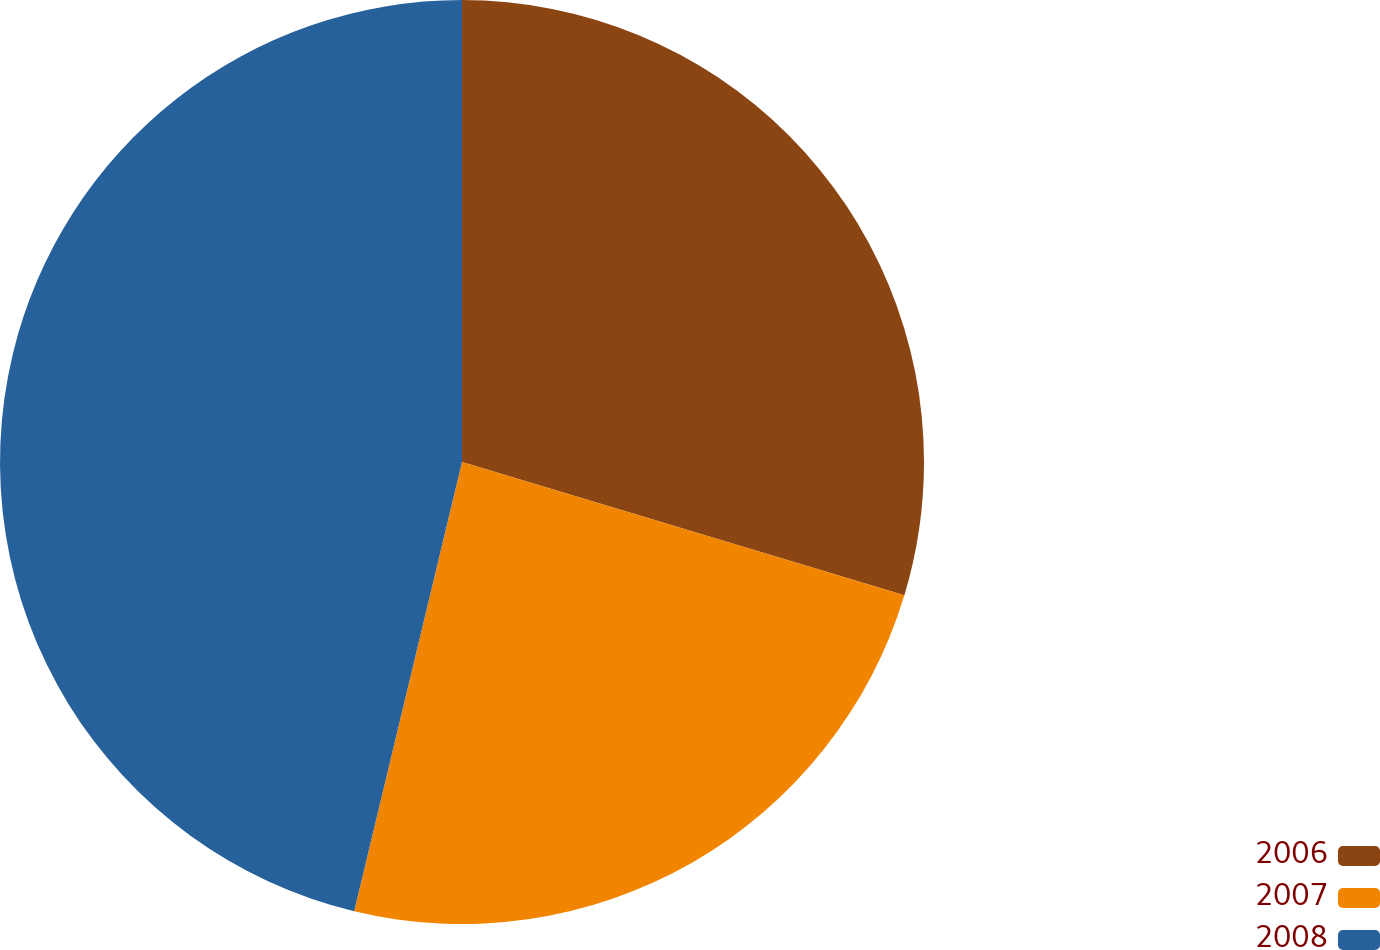Convert chart. <chart><loc_0><loc_0><loc_500><loc_500><pie_chart><fcel>2006<fcel>2007<fcel>2008<nl><fcel>29.66%<fcel>24.09%<fcel>46.25%<nl></chart> 